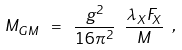Convert formula to latex. <formula><loc_0><loc_0><loc_500><loc_500>M _ { G M } \ = \ \frac { g ^ { 2 } } { 1 6 \pi ^ { 2 } } \ \frac { \lambda _ { X } F _ { X } } { M } \ ,</formula> 